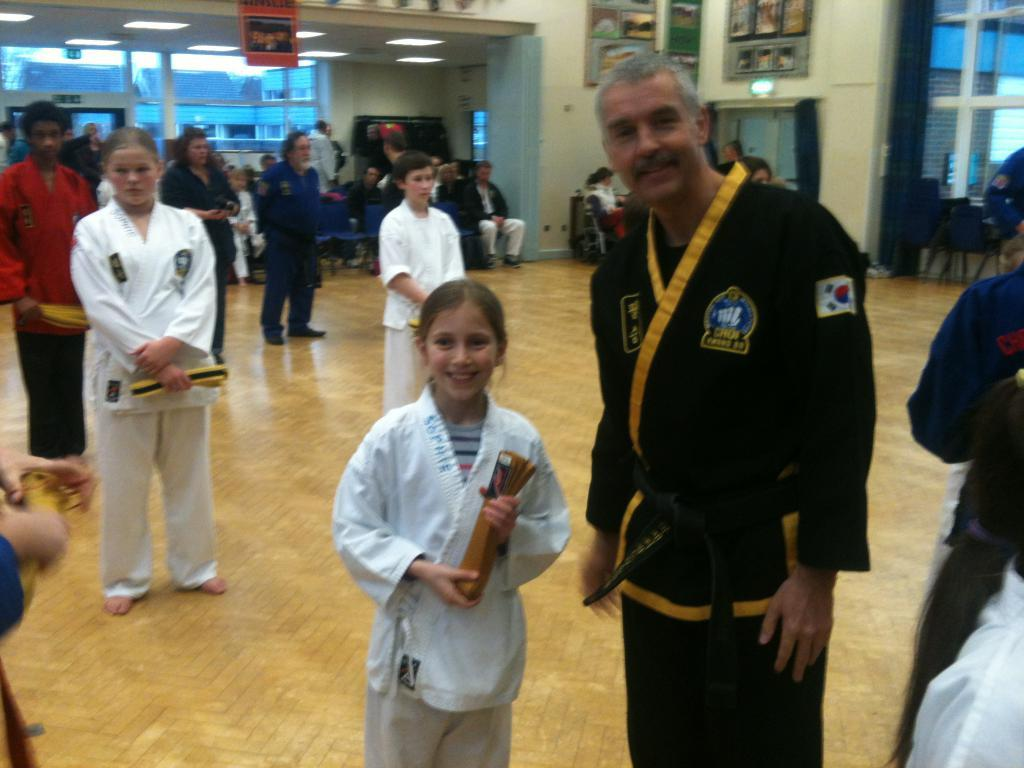Who or what can be seen in the image? There are people in the image. What is the background of the image? There is a wall in the image. Are there any decorative items visible? Photo frames are present in the image. What can be seen providing illumination? Lights are visible in the image. Is there a way to enter or exit the space? There is a door in the image. What type of furniture is present? Chairs are present in the image. Is there a volcano visible in the image? No, there is no volcano present in the image. What type of roof can be seen above the people in the image? There is no roof visible in the image; it is focused on the people and their surroundings. 